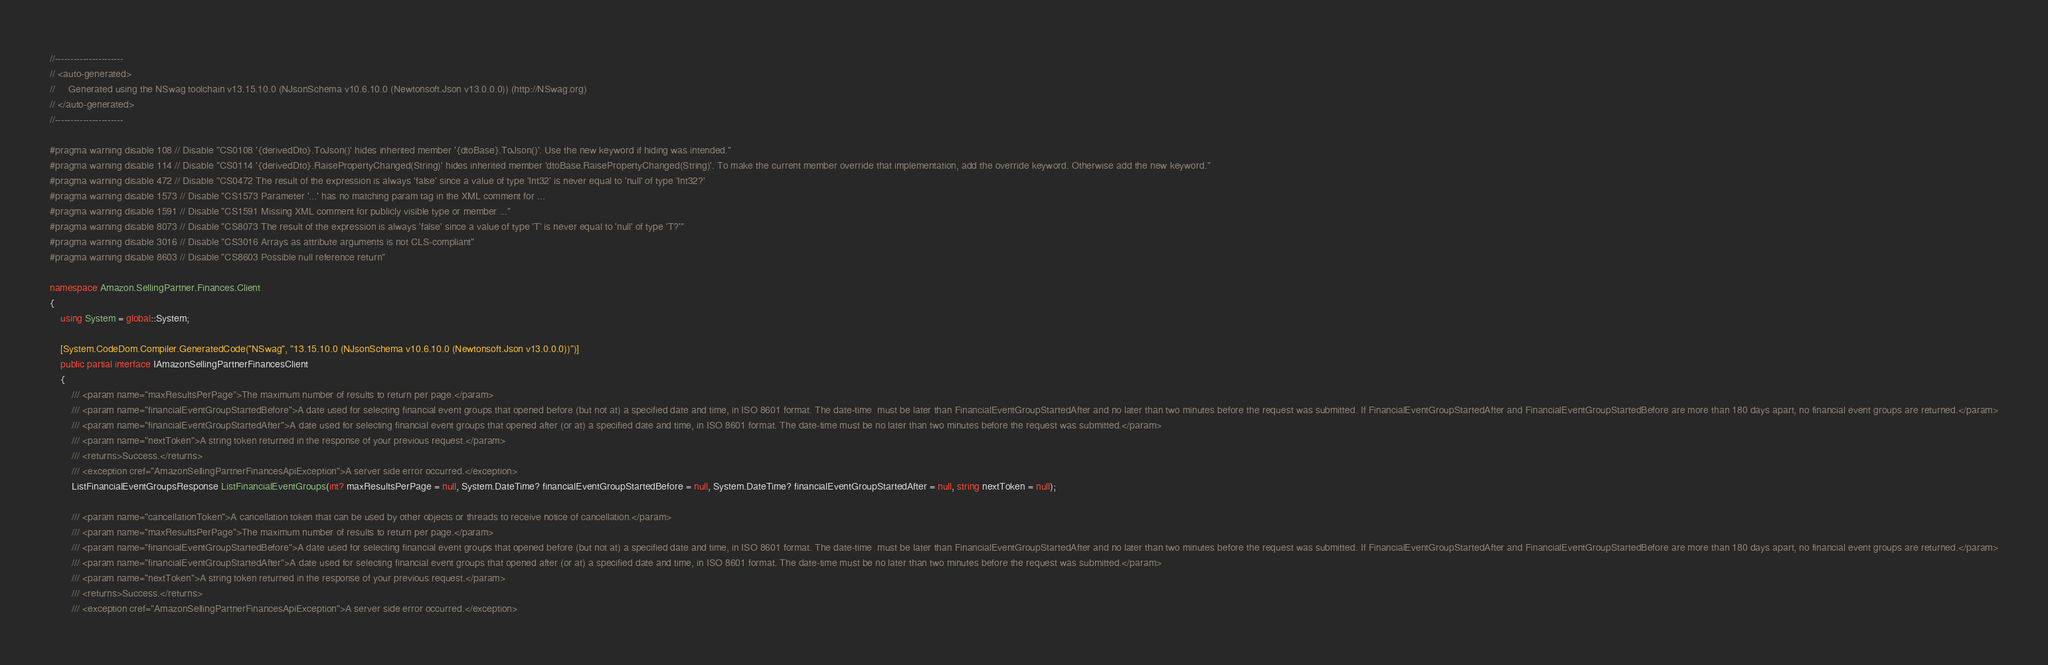Convert code to text. <code><loc_0><loc_0><loc_500><loc_500><_C#_>//----------------------
// <auto-generated>
//     Generated using the NSwag toolchain v13.15.10.0 (NJsonSchema v10.6.10.0 (Newtonsoft.Json v13.0.0.0)) (http://NSwag.org)
// </auto-generated>
//----------------------

#pragma warning disable 108 // Disable "CS0108 '{derivedDto}.ToJson()' hides inherited member '{dtoBase}.ToJson()'. Use the new keyword if hiding was intended."
#pragma warning disable 114 // Disable "CS0114 '{derivedDto}.RaisePropertyChanged(String)' hides inherited member 'dtoBase.RaisePropertyChanged(String)'. To make the current member override that implementation, add the override keyword. Otherwise add the new keyword."
#pragma warning disable 472 // Disable "CS0472 The result of the expression is always 'false' since a value of type 'Int32' is never equal to 'null' of type 'Int32?'
#pragma warning disable 1573 // Disable "CS1573 Parameter '...' has no matching param tag in the XML comment for ...
#pragma warning disable 1591 // Disable "CS1591 Missing XML comment for publicly visible type or member ..."
#pragma warning disable 8073 // Disable "CS8073 The result of the expression is always 'false' since a value of type 'T' is never equal to 'null' of type 'T?'"
#pragma warning disable 3016 // Disable "CS3016 Arrays as attribute arguments is not CLS-compliant"
#pragma warning disable 8603 // Disable "CS8603 Possible null reference return"

namespace Amazon.SellingPartner.Finances.Client
{
    using System = global::System;

    [System.CodeDom.Compiler.GeneratedCode("NSwag", "13.15.10.0 (NJsonSchema v10.6.10.0 (Newtonsoft.Json v13.0.0.0))")]
    public partial interface IAmazonSellingPartnerFinancesClient
    {
        /// <param name="maxResultsPerPage">The maximum number of results to return per page.</param>
        /// <param name="financialEventGroupStartedBefore">A date used for selecting financial event groups that opened before (but not at) a specified date and time, in ISO 8601 format. The date-time  must be later than FinancialEventGroupStartedAfter and no later than two minutes before the request was submitted. If FinancialEventGroupStartedAfter and FinancialEventGroupStartedBefore are more than 180 days apart, no financial event groups are returned.</param>
        /// <param name="financialEventGroupStartedAfter">A date used for selecting financial event groups that opened after (or at) a specified date and time, in ISO 8601 format. The date-time must be no later than two minutes before the request was submitted.</param>
        /// <param name="nextToken">A string token returned in the response of your previous request.</param>
        /// <returns>Success.</returns>
        /// <exception cref="AmazonSellingPartnerFinancesApiException">A server side error occurred.</exception>
        ListFinancialEventGroupsResponse ListFinancialEventGroups(int? maxResultsPerPage = null, System.DateTime? financialEventGroupStartedBefore = null, System.DateTime? financialEventGroupStartedAfter = null, string nextToken = null);

        /// <param name="cancellationToken">A cancellation token that can be used by other objects or threads to receive notice of cancellation.</param>
        /// <param name="maxResultsPerPage">The maximum number of results to return per page.</param>
        /// <param name="financialEventGroupStartedBefore">A date used for selecting financial event groups that opened before (but not at) a specified date and time, in ISO 8601 format. The date-time  must be later than FinancialEventGroupStartedAfter and no later than two minutes before the request was submitted. If FinancialEventGroupStartedAfter and FinancialEventGroupStartedBefore are more than 180 days apart, no financial event groups are returned.</param>
        /// <param name="financialEventGroupStartedAfter">A date used for selecting financial event groups that opened after (or at) a specified date and time, in ISO 8601 format. The date-time must be no later than two minutes before the request was submitted.</param>
        /// <param name="nextToken">A string token returned in the response of your previous request.</param>
        /// <returns>Success.</returns>
        /// <exception cref="AmazonSellingPartnerFinancesApiException">A server side error occurred.</exception></code> 